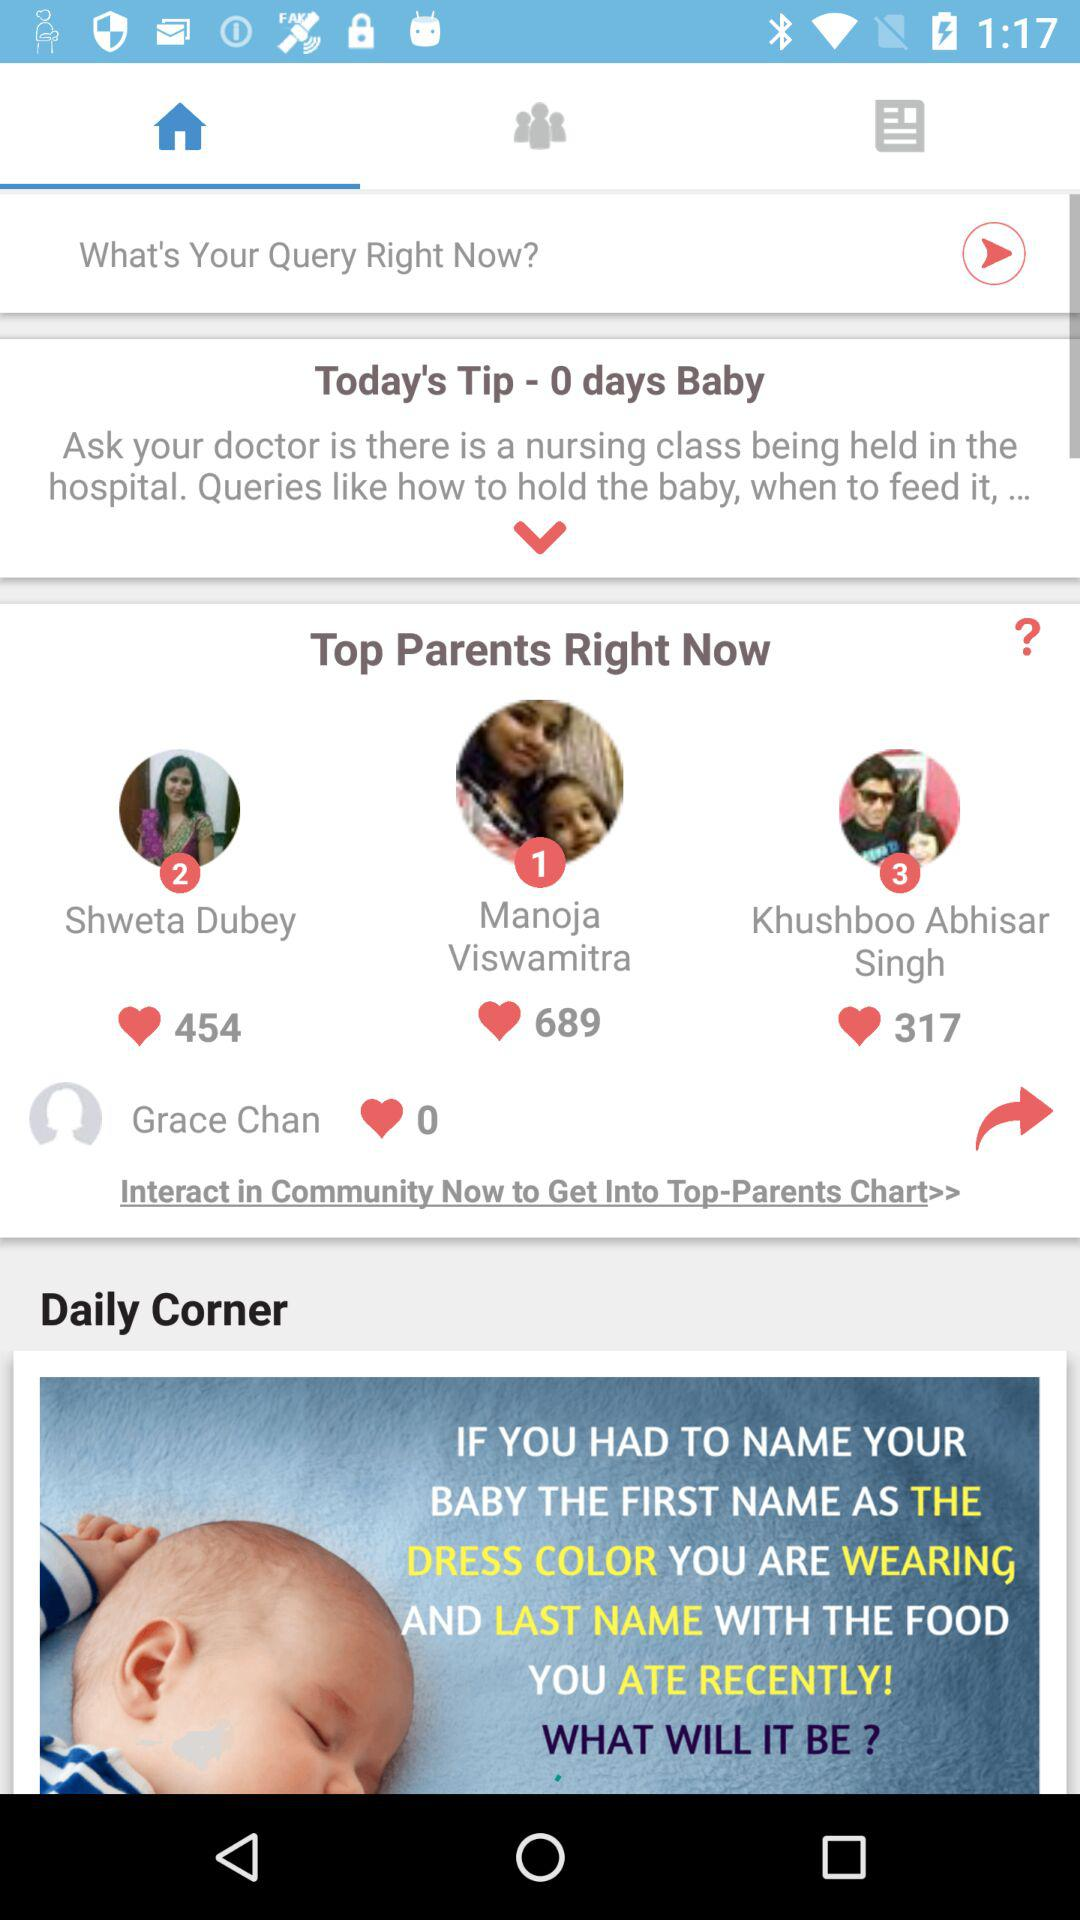How many likes did Shweta Dubey get? Shweta Dubey got 454 likes. 